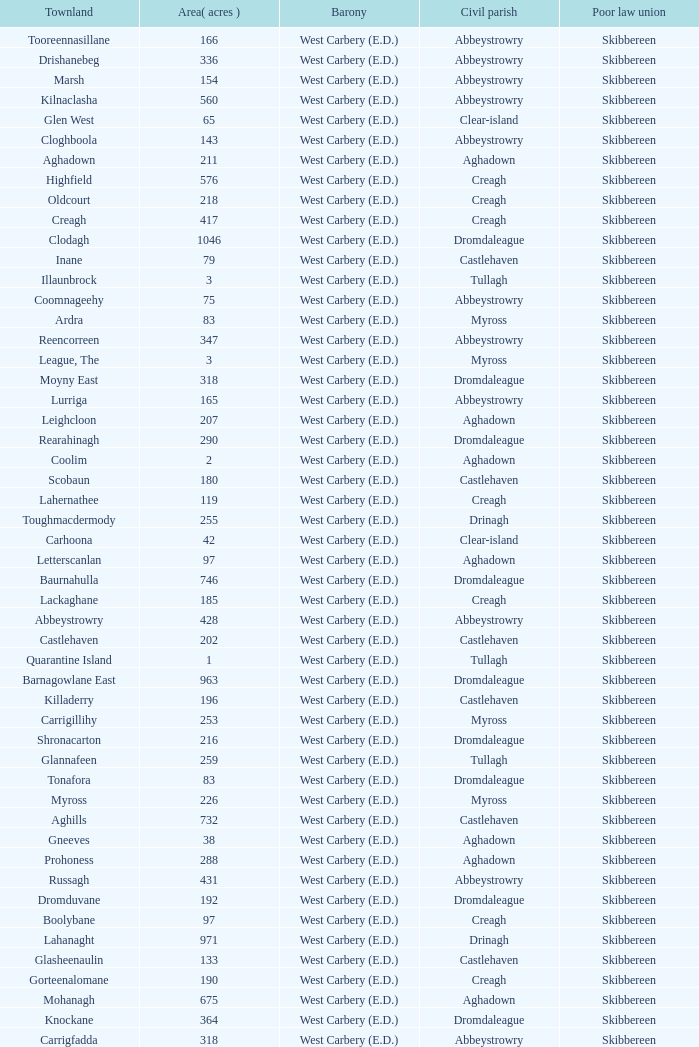What are the Poor Law Unions when the area (in acres) is 142? Skibbereen. 